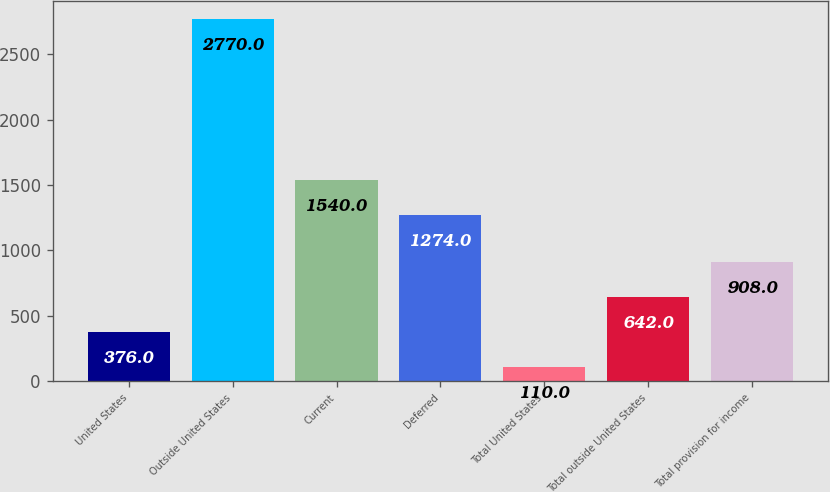Convert chart to OTSL. <chart><loc_0><loc_0><loc_500><loc_500><bar_chart><fcel>United States<fcel>Outside United States<fcel>Current<fcel>Deferred<fcel>Total United States<fcel>Total outside United States<fcel>Total provision for income<nl><fcel>376<fcel>2770<fcel>1540<fcel>1274<fcel>110<fcel>642<fcel>908<nl></chart> 